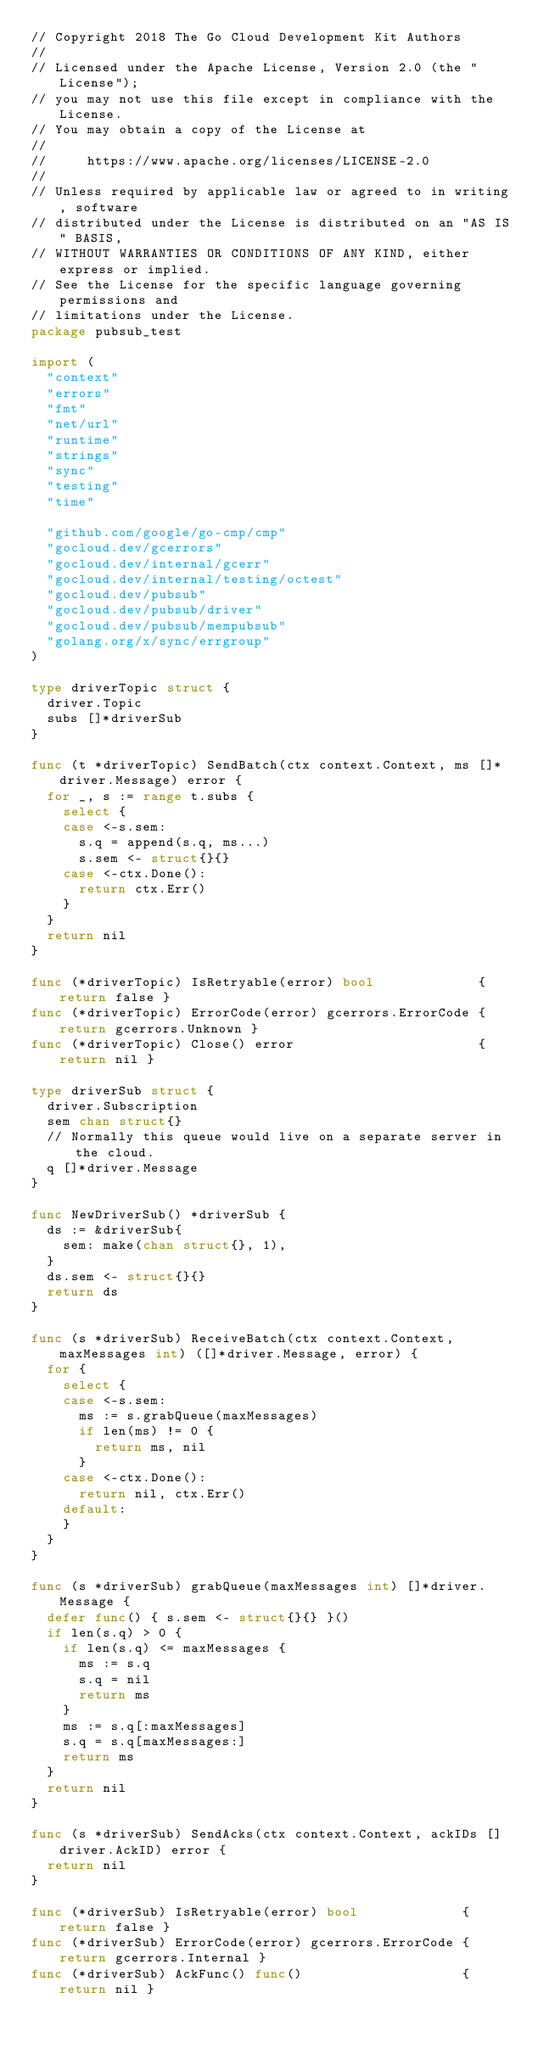Convert code to text. <code><loc_0><loc_0><loc_500><loc_500><_Go_>// Copyright 2018 The Go Cloud Development Kit Authors
//
// Licensed under the Apache License, Version 2.0 (the "License");
// you may not use this file except in compliance with the License.
// You may obtain a copy of the License at
//
//     https://www.apache.org/licenses/LICENSE-2.0
//
// Unless required by applicable law or agreed to in writing, software
// distributed under the License is distributed on an "AS IS" BASIS,
// WITHOUT WARRANTIES OR CONDITIONS OF ANY KIND, either express or implied.
// See the License for the specific language governing permissions and
// limitations under the License.
package pubsub_test

import (
	"context"
	"errors"
	"fmt"
	"net/url"
	"runtime"
	"strings"
	"sync"
	"testing"
	"time"

	"github.com/google/go-cmp/cmp"
	"gocloud.dev/gcerrors"
	"gocloud.dev/internal/gcerr"
	"gocloud.dev/internal/testing/octest"
	"gocloud.dev/pubsub"
	"gocloud.dev/pubsub/driver"
	"gocloud.dev/pubsub/mempubsub"
	"golang.org/x/sync/errgroup"
)

type driverTopic struct {
	driver.Topic
	subs []*driverSub
}

func (t *driverTopic) SendBatch(ctx context.Context, ms []*driver.Message) error {
	for _, s := range t.subs {
		select {
		case <-s.sem:
			s.q = append(s.q, ms...)
			s.sem <- struct{}{}
		case <-ctx.Done():
			return ctx.Err()
		}
	}
	return nil
}

func (*driverTopic) IsRetryable(error) bool             { return false }
func (*driverTopic) ErrorCode(error) gcerrors.ErrorCode { return gcerrors.Unknown }
func (*driverTopic) Close() error                       { return nil }

type driverSub struct {
	driver.Subscription
	sem chan struct{}
	// Normally this queue would live on a separate server in the cloud.
	q []*driver.Message
}

func NewDriverSub() *driverSub {
	ds := &driverSub{
		sem: make(chan struct{}, 1),
	}
	ds.sem <- struct{}{}
	return ds
}

func (s *driverSub) ReceiveBatch(ctx context.Context, maxMessages int) ([]*driver.Message, error) {
	for {
		select {
		case <-s.sem:
			ms := s.grabQueue(maxMessages)
			if len(ms) != 0 {
				return ms, nil
			}
		case <-ctx.Done():
			return nil, ctx.Err()
		default:
		}
	}
}

func (s *driverSub) grabQueue(maxMessages int) []*driver.Message {
	defer func() { s.sem <- struct{}{} }()
	if len(s.q) > 0 {
		if len(s.q) <= maxMessages {
			ms := s.q
			s.q = nil
			return ms
		}
		ms := s.q[:maxMessages]
		s.q = s.q[maxMessages:]
		return ms
	}
	return nil
}

func (s *driverSub) SendAcks(ctx context.Context, ackIDs []driver.AckID) error {
	return nil
}

func (*driverSub) IsRetryable(error) bool             { return false }
func (*driverSub) ErrorCode(error) gcerrors.ErrorCode { return gcerrors.Internal }
func (*driverSub) AckFunc() func()                    { return nil }</code> 